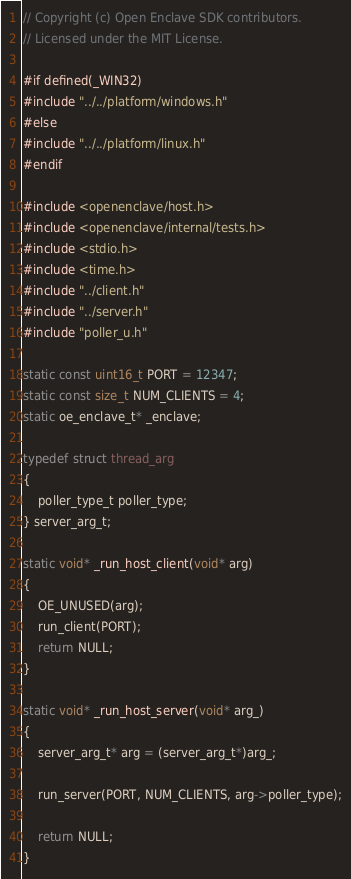Convert code to text. <code><loc_0><loc_0><loc_500><loc_500><_C++_>// Copyright (c) Open Enclave SDK contributors.
// Licensed under the MIT License.

#if defined(_WIN32)
#include "../../platform/windows.h"
#else
#include "../../platform/linux.h"
#endif

#include <openenclave/host.h>
#include <openenclave/internal/tests.h>
#include <stdio.h>
#include <time.h>
#include "../client.h"
#include "../server.h"
#include "poller_u.h"

static const uint16_t PORT = 12347;
static const size_t NUM_CLIENTS = 4;
static oe_enclave_t* _enclave;

typedef struct thread_arg
{
    poller_type_t poller_type;
} server_arg_t;

static void* _run_host_client(void* arg)
{
    OE_UNUSED(arg);
    run_client(PORT);
    return NULL;
}

static void* _run_host_server(void* arg_)
{
    server_arg_t* arg = (server_arg_t*)arg_;

    run_server(PORT, NUM_CLIENTS, arg->poller_type);

    return NULL;
}
</code> 